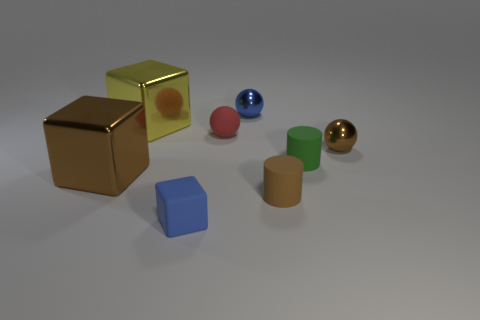Which of these objects is the tallest? Considering the perspectives given in the image, the golden cube seems to be the tallest object. Could you describe its appearance and texture? The golden cube has a reflective, metallic surface with sharp edges, giving it a polished and smooth appearance. 